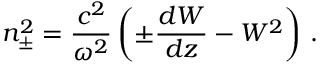<formula> <loc_0><loc_0><loc_500><loc_500>n _ { \pm } ^ { 2 } = \frac { c ^ { 2 } } { \omega ^ { 2 } } \left ( \pm \frac { d W } { d z } - W ^ { 2 } \right ) \, .</formula> 